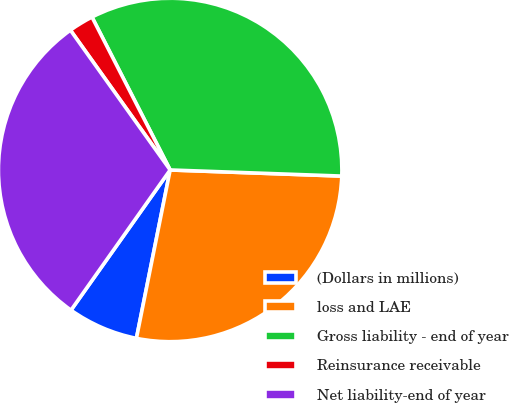Convert chart. <chart><loc_0><loc_0><loc_500><loc_500><pie_chart><fcel>(Dollars in millions)<fcel>loss and LAE<fcel>Gross liability - end of year<fcel>Reinsurance receivable<fcel>Net liability-end of year<nl><fcel>6.65%<fcel>27.58%<fcel>33.09%<fcel>2.34%<fcel>30.34%<nl></chart> 